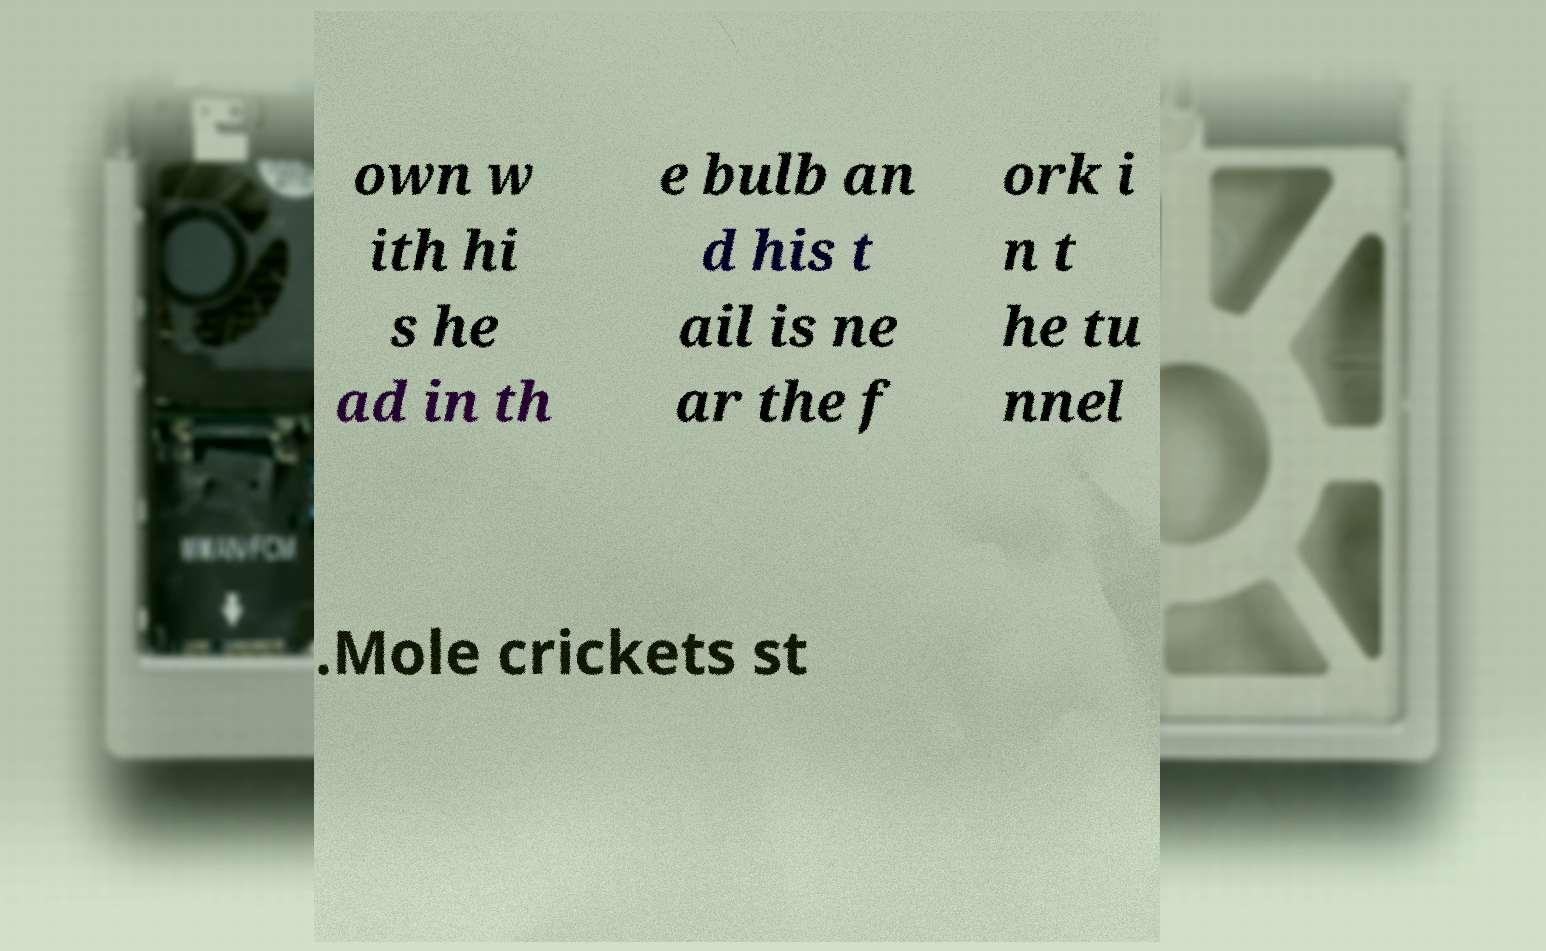What messages or text are displayed in this image? I need them in a readable, typed format. own w ith hi s he ad in th e bulb an d his t ail is ne ar the f ork i n t he tu nnel .Mole crickets st 